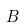<formula> <loc_0><loc_0><loc_500><loc_500>B</formula> 